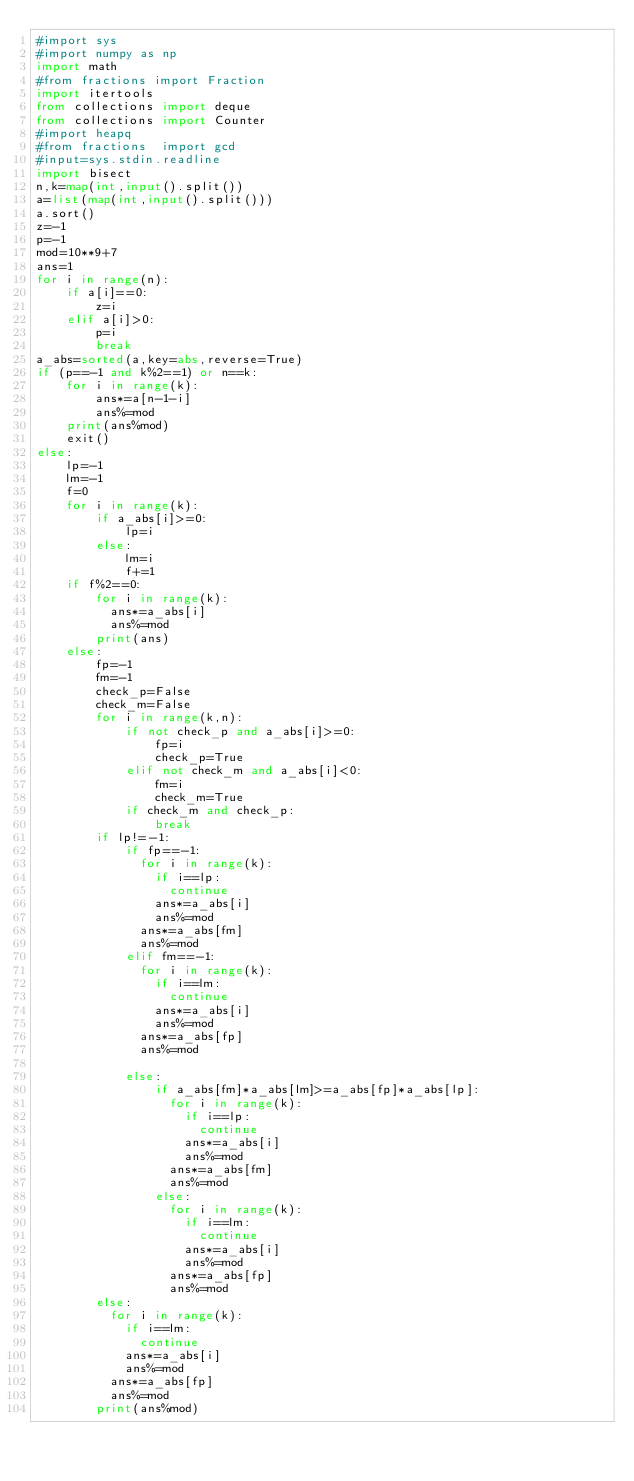<code> <loc_0><loc_0><loc_500><loc_500><_Python_>#import sys
#import numpy as np
import math
#from fractions import Fraction
import itertools
from collections import deque
from collections import Counter
#import heapq
#from fractions  import gcd
#input=sys.stdin.readline
import bisect
n,k=map(int,input().split())
a=list(map(int,input().split()))
a.sort()
z=-1
p=-1
mod=10**9+7
ans=1
for i in range(n):
    if a[i]==0:
        z=i
    elif a[i]>0:
        p=i
        break
a_abs=sorted(a,key=abs,reverse=True)
if (p==-1 and k%2==1) or n==k:
    for i in range(k):
        ans*=a[n-1-i]
        ans%=mod
    print(ans%mod)
    exit()
else:
    lp=-1
    lm=-1
    f=0
    for i in range(k):
        if a_abs[i]>=0:
            lp=i
        else:
            lm=i
            f+=1
    if f%2==0:
        for i in range(k):
          ans*=a_abs[i]
          ans%=mod
        print(ans)
    else:
        fp=-1
        fm=-1
        check_p=False
        check_m=False
        for i in range(k,n):
            if not check_p and a_abs[i]>=0:
                fp=i
                check_p=True
            elif not check_m and a_abs[i]<0:
                fm=i
                check_m=True
            if check_m and check_p:
                break
        if lp!=-1:
            if fp==-1:
              for i in range(k):
                if i==lp:
                  continue
                ans*=a_abs[i]
                ans%=mod
              ans*=a_abs[fm]
              ans%=mod
            elif fm==-1:
              for i in range(k):
                if i==lm:
                  continue
                ans*=a_abs[i]
                ans%=mod
              ans*=a_abs[fp]
              ans%=mod

            else:
                if a_abs[fm]*a_abs[lm]>=a_abs[fp]*a_abs[lp]:
                  for i in range(k):
                    if i==lp:
                      continue
                    ans*=a_abs[i]
                    ans%=mod
                  ans*=a_abs[fm]
                  ans%=mod
                else:
                  for i in range(k):
                    if i==lm:
                      continue
               	    ans*=a_abs[i]
                    ans%=mod
                  ans*=a_abs[fp]
                  ans%=mod
        else:
          for i in range(k):
            if i==lm:
              continue
            ans*=a_abs[i]
            ans%=mod
          ans*=a_abs[fp]
          ans%=mod
        print(ans%mod)</code> 